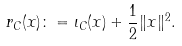<formula> <loc_0><loc_0><loc_500><loc_500>r _ { C } ( x ) \colon = \iota _ { C } ( x ) + \frac { 1 } { 2 } \| x \| ^ { 2 } .</formula> 